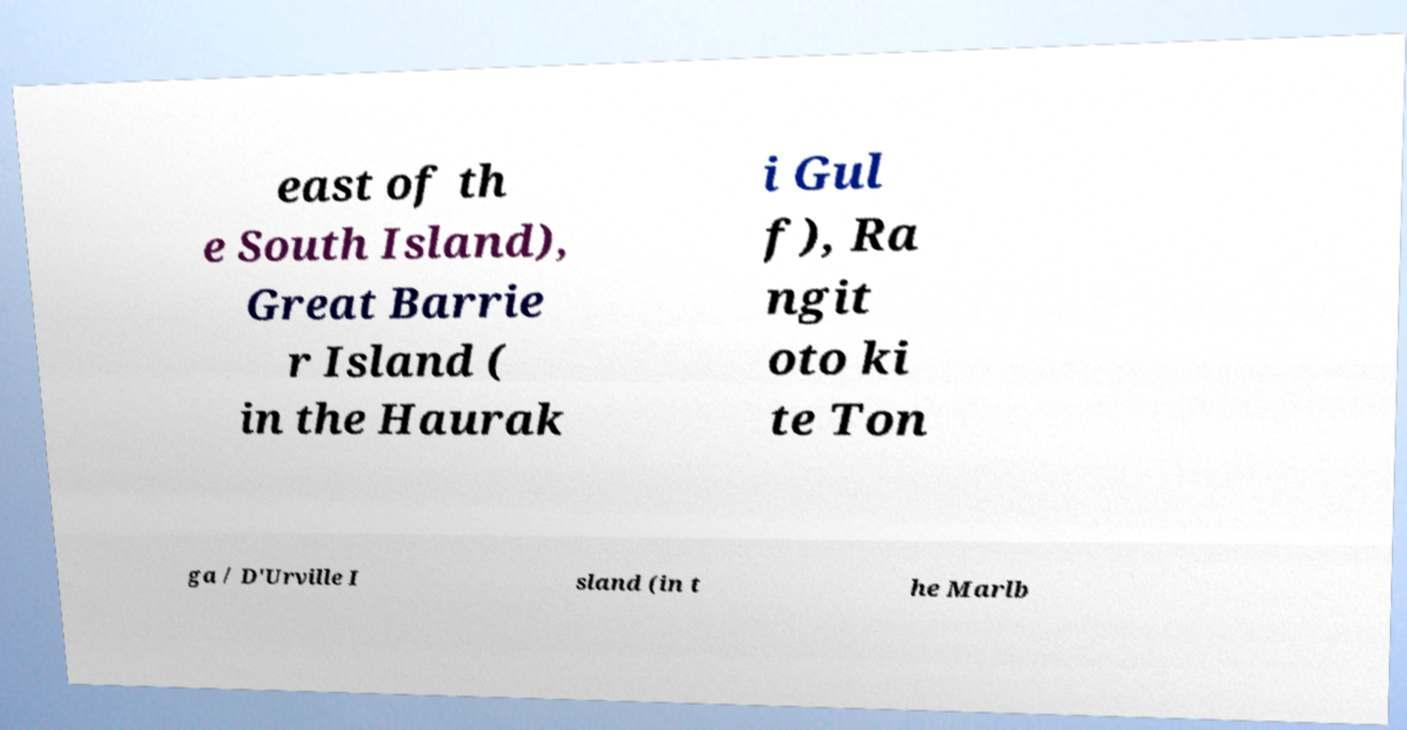Please read and relay the text visible in this image. What does it say? east of th e South Island), Great Barrie r Island ( in the Haurak i Gul f), Ra ngit oto ki te Ton ga / D'Urville I sland (in t he Marlb 